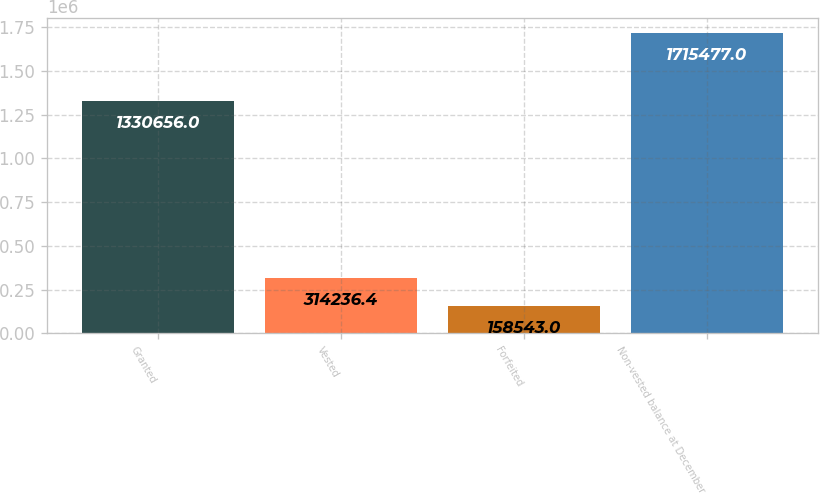<chart> <loc_0><loc_0><loc_500><loc_500><bar_chart><fcel>Granted<fcel>Vested<fcel>Forfeited<fcel>Non-vested balance at December<nl><fcel>1.33066e+06<fcel>314236<fcel>158543<fcel>1.71548e+06<nl></chart> 